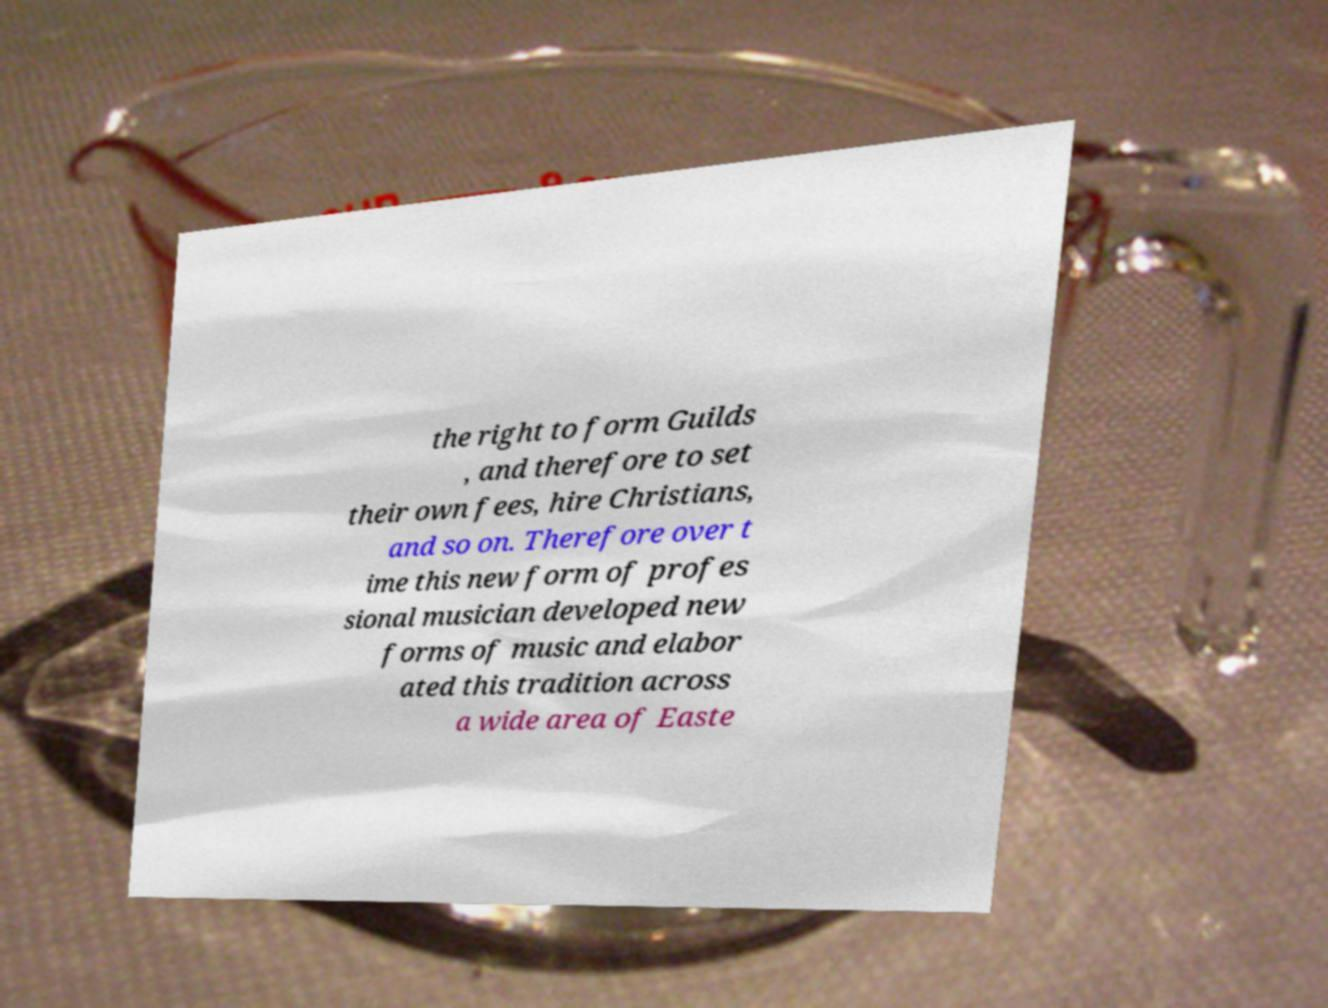Please read and relay the text visible in this image. What does it say? the right to form Guilds , and therefore to set their own fees, hire Christians, and so on. Therefore over t ime this new form of profes sional musician developed new forms of music and elabor ated this tradition across a wide area of Easte 